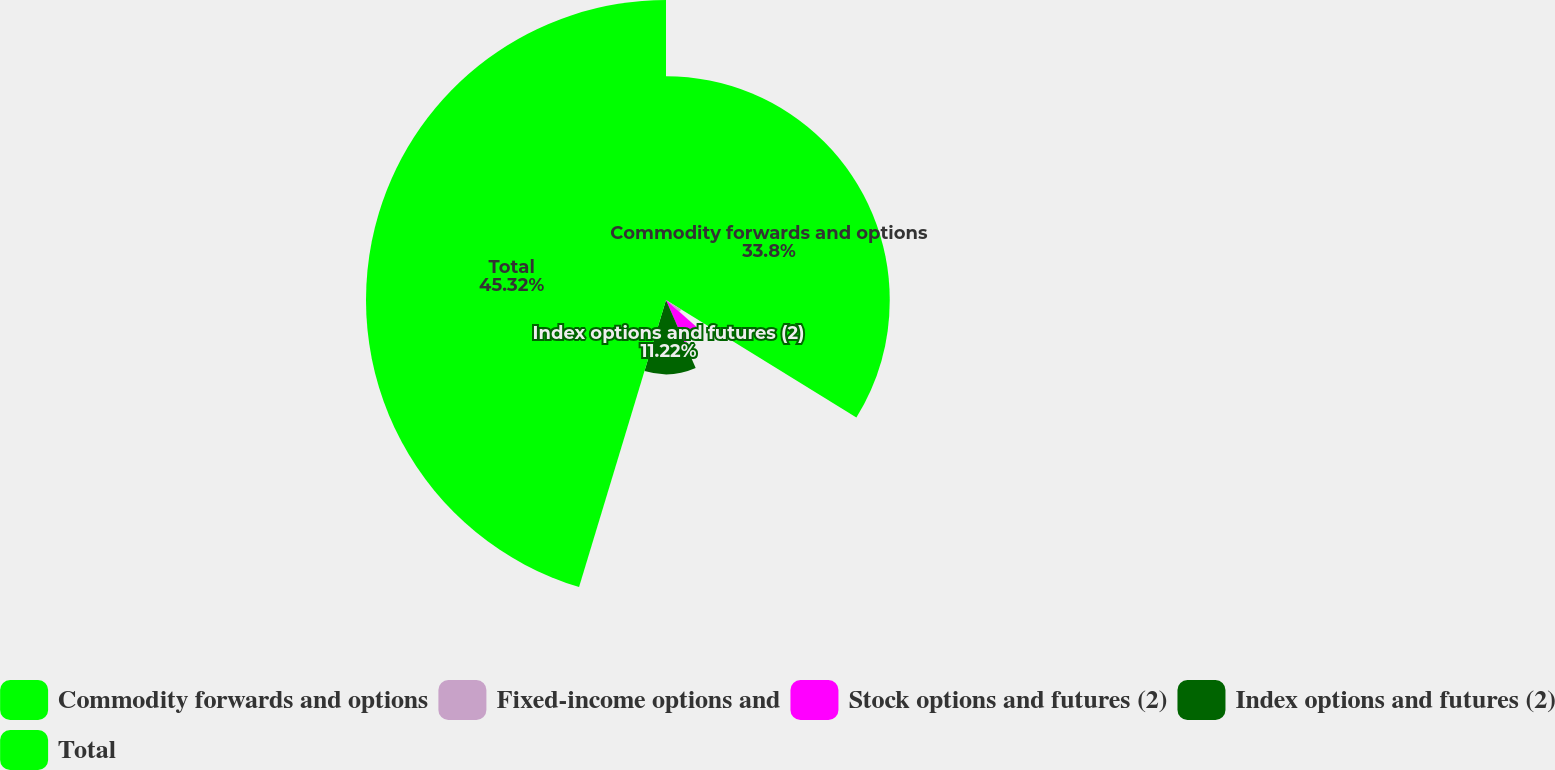Convert chart to OTSL. <chart><loc_0><loc_0><loc_500><loc_500><pie_chart><fcel>Commodity forwards and options<fcel>Fixed-income options and<fcel>Stock options and futures (2)<fcel>Index options and futures (2)<fcel>Total<nl><fcel>33.8%<fcel>2.7%<fcel>6.96%<fcel>11.22%<fcel>45.32%<nl></chart> 